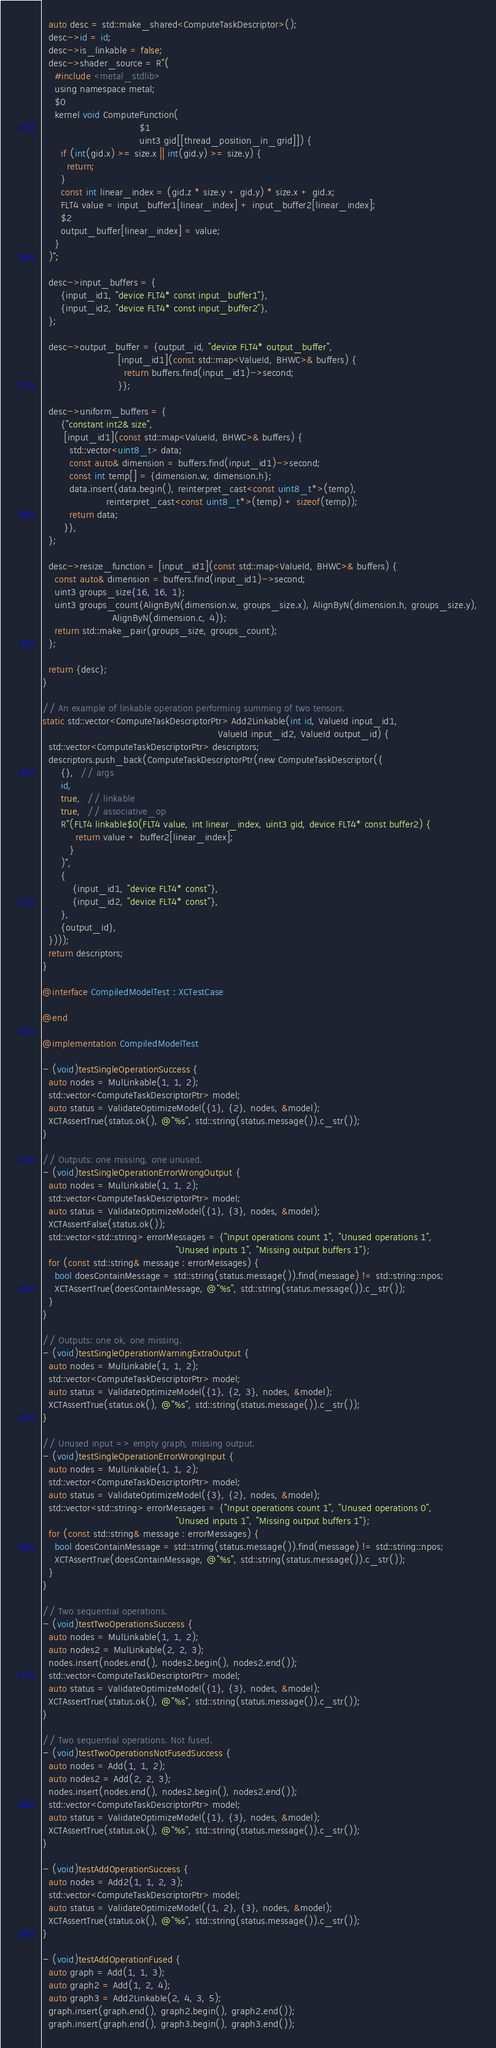Convert code to text. <code><loc_0><loc_0><loc_500><loc_500><_ObjectiveC_>  auto desc = std::make_shared<ComputeTaskDescriptor>();
  desc->id = id;
  desc->is_linkable = false;
  desc->shader_source = R"(
    #include <metal_stdlib>
    using namespace metal;
    $0
    kernel void ComputeFunction(
                                $1
                                uint3 gid[[thread_position_in_grid]]) {
      if (int(gid.x) >= size.x || int(gid.y) >= size.y) {
        return;
      }
      const int linear_index = (gid.z * size.y + gid.y) * size.x + gid.x;
      FLT4 value = input_buffer1[linear_index] + input_buffer2[linear_index];
      $2
      output_buffer[linear_index] = value;
    }
  )";

  desc->input_buffers = {
      {input_id1, "device FLT4* const input_buffer1"},
      {input_id2, "device FLT4* const input_buffer2"},
  };

  desc->output_buffer = {output_id, "device FLT4* output_buffer",
                         [input_id1](const std::map<ValueId, BHWC>& buffers) {
                           return buffers.find(input_id1)->second;
                         }};

  desc->uniform_buffers = {
      {"constant int2& size",
       [input_id1](const std::map<ValueId, BHWC>& buffers) {
         std::vector<uint8_t> data;
         const auto& dimension = buffers.find(input_id1)->second;
         const int temp[] = {dimension.w, dimension.h};
         data.insert(data.begin(), reinterpret_cast<const uint8_t*>(temp),
                     reinterpret_cast<const uint8_t*>(temp) + sizeof(temp));
         return data;
       }},
  };

  desc->resize_function = [input_id1](const std::map<ValueId, BHWC>& buffers) {
    const auto& dimension = buffers.find(input_id1)->second;
    uint3 groups_size{16, 16, 1};
    uint3 groups_count{AlignByN(dimension.w, groups_size.x), AlignByN(dimension.h, groups_size.y),
                       AlignByN(dimension.c, 4)};
    return std::make_pair(groups_size, groups_count);
  };

  return {desc};
}

// An example of linkable operation performing summing of two tensors.
static std::vector<ComputeTaskDescriptorPtr> Add2Linkable(int id, ValueId input_id1,
                                                          ValueId input_id2, ValueId output_id) {
  std::vector<ComputeTaskDescriptorPtr> descriptors;
  descriptors.push_back(ComputeTaskDescriptorPtr(new ComputeTaskDescriptor({
      {},  // args
      id,
      true,  // linkable
      true,  // associative_op
      R"(FLT4 linkable$0(FLT4 value, int linear_index, uint3 gid, device FLT4* const buffer2) {
           return value + buffer2[linear_index];
         }
      )",
      {
          {input_id1, "device FLT4* const"},
          {input_id2, "device FLT4* const"},
      },
      {output_id},
  })));
  return descriptors;
}

@interface CompiledModelTest : XCTestCase

@end

@implementation CompiledModelTest

- (void)testSingleOperationSuccess {
  auto nodes = MulLinkable(1, 1, 2);
  std::vector<ComputeTaskDescriptorPtr> model;
  auto status = ValidateOptimizeModel({1}, {2}, nodes, &model);
  XCTAssertTrue(status.ok(), @"%s", std::string(status.message()).c_str());
}

// Outputs: one missing, one unused.
- (void)testSingleOperationErrorWrongOutput {
  auto nodes = MulLinkable(1, 1, 2);
  std::vector<ComputeTaskDescriptorPtr> model;
  auto status = ValidateOptimizeModel({1}, {3}, nodes, &model);
  XCTAssertFalse(status.ok());
  std::vector<std::string> errorMessages = {"Input operations count 1", "Unused operations 1",
                                            "Unused inputs 1", "Missing output buffers 1"};
  for (const std::string& message : errorMessages) {
    bool doesContainMessage = std::string(status.message()).find(message) != std::string::npos;
    XCTAssertTrue(doesContainMessage, @"%s", std::string(status.message()).c_str());
  }
}

// Outputs: one ok, one missing.
- (void)testSingleOperationWarningExtraOutput {
  auto nodes = MulLinkable(1, 1, 2);
  std::vector<ComputeTaskDescriptorPtr> model;
  auto status = ValidateOptimizeModel({1}, {2, 3}, nodes, &model);
  XCTAssertTrue(status.ok(), @"%s", std::string(status.message()).c_str());
}

// Unused input => empty graph, missing output.
- (void)testSingleOperationErrorWrongInput {
  auto nodes = MulLinkable(1, 1, 2);
  std::vector<ComputeTaskDescriptorPtr> model;
  auto status = ValidateOptimizeModel({3}, {2}, nodes, &model);
  std::vector<std::string> errorMessages = {"Input operations count 1", "Unused operations 0",
                                            "Unused inputs 1", "Missing output buffers 1"};
  for (const std::string& message : errorMessages) {
    bool doesContainMessage = std::string(status.message()).find(message) != std::string::npos;
    XCTAssertTrue(doesContainMessage, @"%s", std::string(status.message()).c_str());
  }
}

// Two sequential operations.
- (void)testTwoOperationsSuccess {
  auto nodes = MulLinkable(1, 1, 2);
  auto nodes2 = MulLinkable(2, 2, 3);
  nodes.insert(nodes.end(), nodes2.begin(), nodes2.end());
  std::vector<ComputeTaskDescriptorPtr> model;
  auto status = ValidateOptimizeModel({1}, {3}, nodes, &model);
  XCTAssertTrue(status.ok(), @"%s", std::string(status.message()).c_str());
}

// Two sequential operations. Not fused.
- (void)testTwoOperationsNotFusedSuccess {
  auto nodes = Add(1, 1, 2);
  auto nodes2 = Add(2, 2, 3);
  nodes.insert(nodes.end(), nodes2.begin(), nodes2.end());
  std::vector<ComputeTaskDescriptorPtr> model;
  auto status = ValidateOptimizeModel({1}, {3}, nodes, &model);
  XCTAssertTrue(status.ok(), @"%s", std::string(status.message()).c_str());
}

- (void)testAddOperationSuccess {
  auto nodes = Add2(1, 1, 2, 3);
  std::vector<ComputeTaskDescriptorPtr> model;
  auto status = ValidateOptimizeModel({1, 2}, {3}, nodes, &model);
  XCTAssertTrue(status.ok(), @"%s", std::string(status.message()).c_str());
}

- (void)testAddOperationFused {
  auto graph = Add(1, 1, 3);
  auto graph2 = Add(1, 2, 4);
  auto graph3 = Add2Linkable(2, 4, 3, 5);
  graph.insert(graph.end(), graph2.begin(), graph2.end());
  graph.insert(graph.end(), graph3.begin(), graph3.end());</code> 